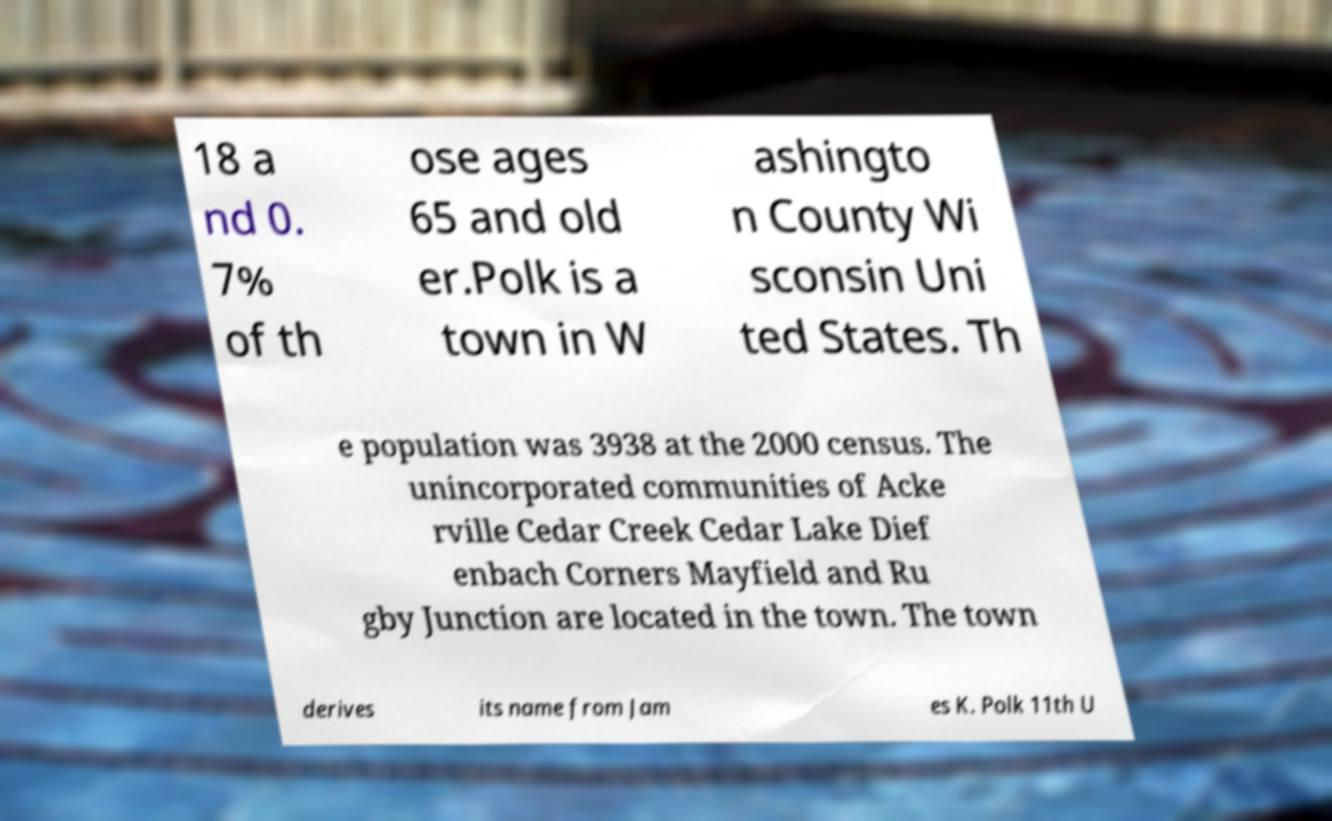What messages or text are displayed in this image? I need them in a readable, typed format. 18 a nd 0. 7% of th ose ages 65 and old er.Polk is a town in W ashingto n County Wi sconsin Uni ted States. Th e population was 3938 at the 2000 census. The unincorporated communities of Acke rville Cedar Creek Cedar Lake Dief enbach Corners Mayfield and Ru gby Junction are located in the town. The town derives its name from Jam es K. Polk 11th U 